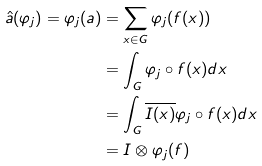<formula> <loc_0><loc_0><loc_500><loc_500>\hat { a } ( \varphi _ { j } ) = \varphi _ { j } ( a ) & = \sum _ { x \in G } \varphi _ { j } ( f ( x ) ) \\ & = \int _ { G } \varphi _ { j } \circ f ( x ) d x \\ & = \int _ { G } \overline { I ( x ) } \varphi _ { j } \circ f ( x ) d x \\ & = I \otimes \varphi _ { j } ( f )</formula> 